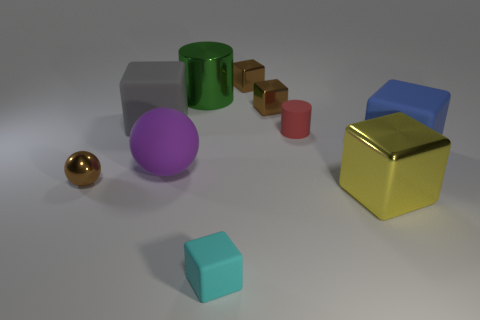How many large things are either blue rubber objects or metal cylinders?
Keep it short and to the point. 2. Is the number of blue metal objects less than the number of small brown things?
Your answer should be compact. Yes. Is there any other thing that has the same size as the brown metallic sphere?
Offer a very short reply. Yes. Is the color of the matte cylinder the same as the big shiny block?
Provide a short and direct response. No. Is the number of large things greater than the number of cyan rubber cylinders?
Offer a terse response. Yes. What number of other objects are the same color as the rubber cylinder?
Ensure brevity in your answer.  0. How many gray matte things are on the right side of the shiny block in front of the small ball?
Keep it short and to the point. 0. Are there any big blocks to the left of the large purple sphere?
Your response must be concise. Yes. There is a large metallic thing behind the rubber block left of the large cylinder; what is its shape?
Ensure brevity in your answer.  Cylinder. Is the number of purple rubber balls in front of the small cyan object less than the number of tiny matte cylinders right of the red rubber cylinder?
Ensure brevity in your answer.  No. 